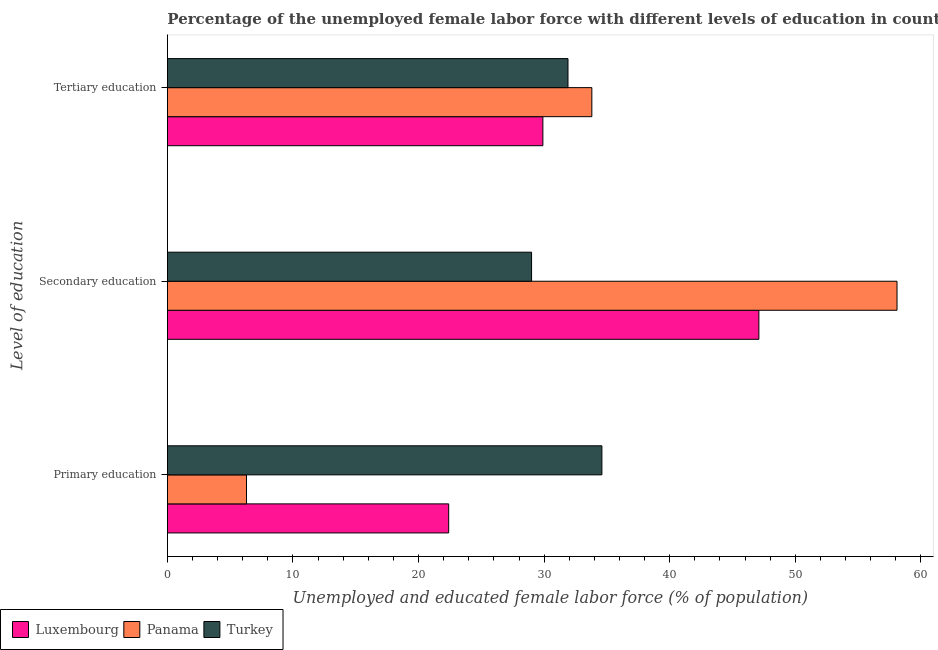Are the number of bars on each tick of the Y-axis equal?
Make the answer very short. Yes. What is the label of the 2nd group of bars from the top?
Provide a short and direct response. Secondary education. What is the percentage of female labor force who received primary education in Panama?
Your response must be concise. 6.3. Across all countries, what is the maximum percentage of female labor force who received secondary education?
Your response must be concise. 58.1. Across all countries, what is the minimum percentage of female labor force who received tertiary education?
Give a very brief answer. 29.9. In which country was the percentage of female labor force who received tertiary education maximum?
Your answer should be compact. Panama. In which country was the percentage of female labor force who received tertiary education minimum?
Your response must be concise. Luxembourg. What is the total percentage of female labor force who received primary education in the graph?
Offer a very short reply. 63.3. What is the difference between the percentage of female labor force who received secondary education in Turkey and that in Luxembourg?
Your response must be concise. -18.1. What is the difference between the percentage of female labor force who received secondary education in Luxembourg and the percentage of female labor force who received tertiary education in Turkey?
Offer a terse response. 15.2. What is the average percentage of female labor force who received tertiary education per country?
Your answer should be very brief. 31.87. What is the difference between the percentage of female labor force who received secondary education and percentage of female labor force who received tertiary education in Luxembourg?
Keep it short and to the point. 17.2. In how many countries, is the percentage of female labor force who received tertiary education greater than 22 %?
Keep it short and to the point. 3. What is the ratio of the percentage of female labor force who received tertiary education in Turkey to that in Panama?
Your answer should be very brief. 0.94. Is the difference between the percentage of female labor force who received primary education in Luxembourg and Panama greater than the difference between the percentage of female labor force who received tertiary education in Luxembourg and Panama?
Make the answer very short. Yes. What is the difference between the highest and the second highest percentage of female labor force who received tertiary education?
Provide a succinct answer. 1.9. What is the difference between the highest and the lowest percentage of female labor force who received secondary education?
Offer a very short reply. 29.1. In how many countries, is the percentage of female labor force who received primary education greater than the average percentage of female labor force who received primary education taken over all countries?
Keep it short and to the point. 2. Is the sum of the percentage of female labor force who received secondary education in Turkey and Panama greater than the maximum percentage of female labor force who received tertiary education across all countries?
Offer a very short reply. Yes. What does the 2nd bar from the top in Primary education represents?
Offer a terse response. Panama. What does the 2nd bar from the bottom in Tertiary education represents?
Give a very brief answer. Panama. How many bars are there?
Offer a very short reply. 9. How many countries are there in the graph?
Your response must be concise. 3. Are the values on the major ticks of X-axis written in scientific E-notation?
Your answer should be very brief. No. Does the graph contain any zero values?
Your answer should be compact. No. Does the graph contain grids?
Ensure brevity in your answer.  No. How are the legend labels stacked?
Offer a very short reply. Horizontal. What is the title of the graph?
Make the answer very short. Percentage of the unemployed female labor force with different levels of education in countries. What is the label or title of the X-axis?
Give a very brief answer. Unemployed and educated female labor force (% of population). What is the label or title of the Y-axis?
Offer a terse response. Level of education. What is the Unemployed and educated female labor force (% of population) in Luxembourg in Primary education?
Offer a terse response. 22.4. What is the Unemployed and educated female labor force (% of population) of Panama in Primary education?
Your response must be concise. 6.3. What is the Unemployed and educated female labor force (% of population) in Turkey in Primary education?
Provide a succinct answer. 34.6. What is the Unemployed and educated female labor force (% of population) of Luxembourg in Secondary education?
Your response must be concise. 47.1. What is the Unemployed and educated female labor force (% of population) of Panama in Secondary education?
Your answer should be very brief. 58.1. What is the Unemployed and educated female labor force (% of population) in Luxembourg in Tertiary education?
Ensure brevity in your answer.  29.9. What is the Unemployed and educated female labor force (% of population) in Panama in Tertiary education?
Offer a terse response. 33.8. What is the Unemployed and educated female labor force (% of population) in Turkey in Tertiary education?
Keep it short and to the point. 31.9. Across all Level of education, what is the maximum Unemployed and educated female labor force (% of population) in Luxembourg?
Your answer should be very brief. 47.1. Across all Level of education, what is the maximum Unemployed and educated female labor force (% of population) of Panama?
Make the answer very short. 58.1. Across all Level of education, what is the maximum Unemployed and educated female labor force (% of population) in Turkey?
Your answer should be very brief. 34.6. Across all Level of education, what is the minimum Unemployed and educated female labor force (% of population) of Luxembourg?
Provide a short and direct response. 22.4. Across all Level of education, what is the minimum Unemployed and educated female labor force (% of population) in Panama?
Keep it short and to the point. 6.3. What is the total Unemployed and educated female labor force (% of population) of Luxembourg in the graph?
Your response must be concise. 99.4. What is the total Unemployed and educated female labor force (% of population) of Panama in the graph?
Your response must be concise. 98.2. What is the total Unemployed and educated female labor force (% of population) in Turkey in the graph?
Your answer should be compact. 95.5. What is the difference between the Unemployed and educated female labor force (% of population) of Luxembourg in Primary education and that in Secondary education?
Give a very brief answer. -24.7. What is the difference between the Unemployed and educated female labor force (% of population) in Panama in Primary education and that in Secondary education?
Your answer should be compact. -51.8. What is the difference between the Unemployed and educated female labor force (% of population) in Luxembourg in Primary education and that in Tertiary education?
Ensure brevity in your answer.  -7.5. What is the difference between the Unemployed and educated female labor force (% of population) of Panama in Primary education and that in Tertiary education?
Keep it short and to the point. -27.5. What is the difference between the Unemployed and educated female labor force (% of population) in Luxembourg in Secondary education and that in Tertiary education?
Keep it short and to the point. 17.2. What is the difference between the Unemployed and educated female labor force (% of population) of Panama in Secondary education and that in Tertiary education?
Your answer should be compact. 24.3. What is the difference between the Unemployed and educated female labor force (% of population) in Luxembourg in Primary education and the Unemployed and educated female labor force (% of population) in Panama in Secondary education?
Offer a very short reply. -35.7. What is the difference between the Unemployed and educated female labor force (% of population) in Panama in Primary education and the Unemployed and educated female labor force (% of population) in Turkey in Secondary education?
Offer a terse response. -22.7. What is the difference between the Unemployed and educated female labor force (% of population) in Luxembourg in Primary education and the Unemployed and educated female labor force (% of population) in Panama in Tertiary education?
Give a very brief answer. -11.4. What is the difference between the Unemployed and educated female labor force (% of population) of Luxembourg in Primary education and the Unemployed and educated female labor force (% of population) of Turkey in Tertiary education?
Your answer should be very brief. -9.5. What is the difference between the Unemployed and educated female labor force (% of population) of Panama in Primary education and the Unemployed and educated female labor force (% of population) of Turkey in Tertiary education?
Keep it short and to the point. -25.6. What is the difference between the Unemployed and educated female labor force (% of population) of Luxembourg in Secondary education and the Unemployed and educated female labor force (% of population) of Panama in Tertiary education?
Provide a short and direct response. 13.3. What is the difference between the Unemployed and educated female labor force (% of population) of Luxembourg in Secondary education and the Unemployed and educated female labor force (% of population) of Turkey in Tertiary education?
Offer a terse response. 15.2. What is the difference between the Unemployed and educated female labor force (% of population) in Panama in Secondary education and the Unemployed and educated female labor force (% of population) in Turkey in Tertiary education?
Keep it short and to the point. 26.2. What is the average Unemployed and educated female labor force (% of population) of Luxembourg per Level of education?
Provide a succinct answer. 33.13. What is the average Unemployed and educated female labor force (% of population) in Panama per Level of education?
Provide a short and direct response. 32.73. What is the average Unemployed and educated female labor force (% of population) in Turkey per Level of education?
Offer a very short reply. 31.83. What is the difference between the Unemployed and educated female labor force (% of population) in Panama and Unemployed and educated female labor force (% of population) in Turkey in Primary education?
Give a very brief answer. -28.3. What is the difference between the Unemployed and educated female labor force (% of population) of Luxembourg and Unemployed and educated female labor force (% of population) of Panama in Secondary education?
Offer a terse response. -11. What is the difference between the Unemployed and educated female labor force (% of population) of Panama and Unemployed and educated female labor force (% of population) of Turkey in Secondary education?
Provide a short and direct response. 29.1. What is the difference between the Unemployed and educated female labor force (% of population) of Luxembourg and Unemployed and educated female labor force (% of population) of Turkey in Tertiary education?
Give a very brief answer. -2. What is the difference between the Unemployed and educated female labor force (% of population) in Panama and Unemployed and educated female labor force (% of population) in Turkey in Tertiary education?
Offer a very short reply. 1.9. What is the ratio of the Unemployed and educated female labor force (% of population) of Luxembourg in Primary education to that in Secondary education?
Your answer should be very brief. 0.48. What is the ratio of the Unemployed and educated female labor force (% of population) in Panama in Primary education to that in Secondary education?
Your answer should be very brief. 0.11. What is the ratio of the Unemployed and educated female labor force (% of population) of Turkey in Primary education to that in Secondary education?
Provide a succinct answer. 1.19. What is the ratio of the Unemployed and educated female labor force (% of population) in Luxembourg in Primary education to that in Tertiary education?
Your answer should be very brief. 0.75. What is the ratio of the Unemployed and educated female labor force (% of population) in Panama in Primary education to that in Tertiary education?
Make the answer very short. 0.19. What is the ratio of the Unemployed and educated female labor force (% of population) in Turkey in Primary education to that in Tertiary education?
Keep it short and to the point. 1.08. What is the ratio of the Unemployed and educated female labor force (% of population) in Luxembourg in Secondary education to that in Tertiary education?
Your answer should be compact. 1.58. What is the ratio of the Unemployed and educated female labor force (% of population) in Panama in Secondary education to that in Tertiary education?
Offer a very short reply. 1.72. What is the ratio of the Unemployed and educated female labor force (% of population) of Turkey in Secondary education to that in Tertiary education?
Your response must be concise. 0.91. What is the difference between the highest and the second highest Unemployed and educated female labor force (% of population) of Panama?
Your answer should be very brief. 24.3. What is the difference between the highest and the second highest Unemployed and educated female labor force (% of population) of Turkey?
Provide a short and direct response. 2.7. What is the difference between the highest and the lowest Unemployed and educated female labor force (% of population) of Luxembourg?
Keep it short and to the point. 24.7. What is the difference between the highest and the lowest Unemployed and educated female labor force (% of population) in Panama?
Your answer should be compact. 51.8. What is the difference between the highest and the lowest Unemployed and educated female labor force (% of population) of Turkey?
Keep it short and to the point. 5.6. 